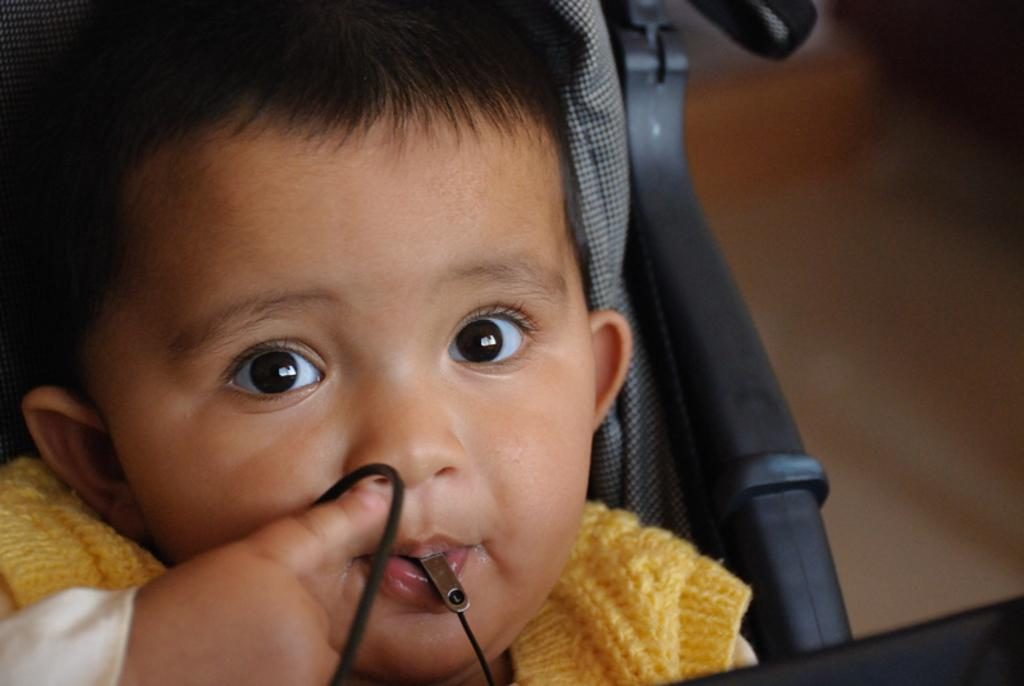Who is the main subject in the image? There is a boy in the image. What is the boy doing in the image? The boy is on an object. Can you describe the background of the image? The background of the image is blurred. What sound does the boy's thumb make in the image? There is no mention of a sound or a thumb in the image, so it cannot be determined what sound, if any, the boy's thumb might make. 